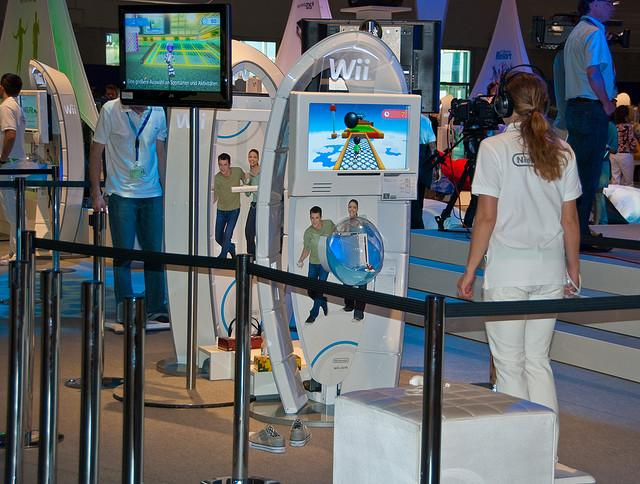What consumer electronic company made the white gaming displays? nintendo 